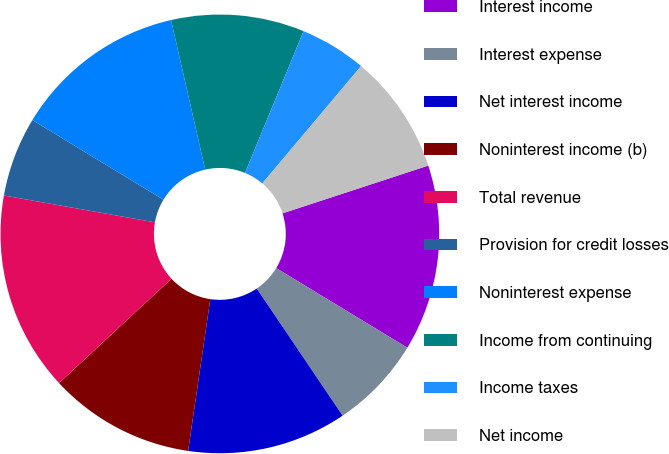Convert chart. <chart><loc_0><loc_0><loc_500><loc_500><pie_chart><fcel>Interest income<fcel>Interest expense<fcel>Net interest income<fcel>Noninterest income (b)<fcel>Total revenue<fcel>Provision for credit losses<fcel>Noninterest expense<fcel>Income from continuing<fcel>Income taxes<fcel>Net income<nl><fcel>13.72%<fcel>6.86%<fcel>11.76%<fcel>10.78%<fcel>14.7%<fcel>5.88%<fcel>12.74%<fcel>9.8%<fcel>4.9%<fcel>8.82%<nl></chart> 